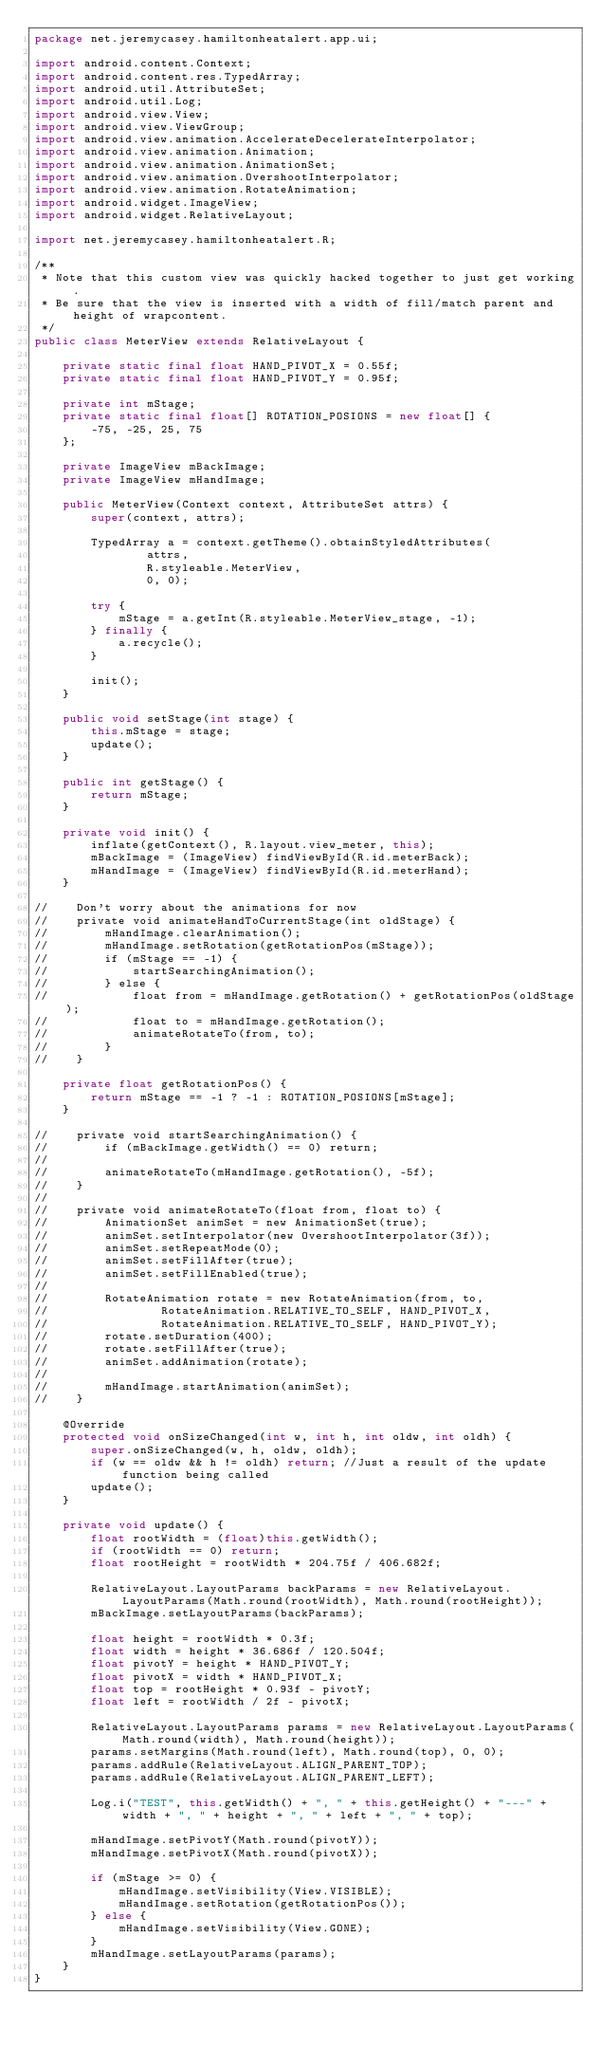<code> <loc_0><loc_0><loc_500><loc_500><_Java_>package net.jeremycasey.hamiltonheatalert.app.ui;

import android.content.Context;
import android.content.res.TypedArray;
import android.util.AttributeSet;
import android.util.Log;
import android.view.View;
import android.view.ViewGroup;
import android.view.animation.AccelerateDecelerateInterpolator;
import android.view.animation.Animation;
import android.view.animation.AnimationSet;
import android.view.animation.OvershootInterpolator;
import android.view.animation.RotateAnimation;
import android.widget.ImageView;
import android.widget.RelativeLayout;

import net.jeremycasey.hamiltonheatalert.R;

/**
 * Note that this custom view was quickly hacked together to just get working.
 * Be sure that the view is inserted with a width of fill/match parent and height of wrapcontent.
 */
public class MeterView extends RelativeLayout {

    private static final float HAND_PIVOT_X = 0.55f;
    private static final float HAND_PIVOT_Y = 0.95f;

    private int mStage;
    private static final float[] ROTATION_POSIONS = new float[] {
        -75, -25, 25, 75
    };

    private ImageView mBackImage;
    private ImageView mHandImage;

    public MeterView(Context context, AttributeSet attrs) {
        super(context, attrs);

        TypedArray a = context.getTheme().obtainStyledAttributes(
                attrs,
                R.styleable.MeterView,
                0, 0);

        try {
            mStage = a.getInt(R.styleable.MeterView_stage, -1);
        } finally {
            a.recycle();
        }

        init();
    }

    public void setStage(int stage) {
        this.mStage = stage;
        update();
    }

    public int getStage() {
        return mStage;
    }

    private void init() {
        inflate(getContext(), R.layout.view_meter, this);
        mBackImage = (ImageView) findViewById(R.id.meterBack);
        mHandImage = (ImageView) findViewById(R.id.meterHand);
    }

//    Don't worry about the animations for now
//    private void animateHandToCurrentStage(int oldStage) {
//        mHandImage.clearAnimation();
//        mHandImage.setRotation(getRotationPos(mStage));
//        if (mStage == -1) {
//            startSearchingAnimation();
//        } else {
//            float from = mHandImage.getRotation() + getRotationPos(oldStage);
//            float to = mHandImage.getRotation();
//            animateRotateTo(from, to);
//        }
//    }

    private float getRotationPos() {
        return mStage == -1 ? -1 : ROTATION_POSIONS[mStage];
    }

//    private void startSearchingAnimation() {
//        if (mBackImage.getWidth() == 0) return;
//
//        animateRotateTo(mHandImage.getRotation(), -5f);
//    }
//
//    private void animateRotateTo(float from, float to) {
//        AnimationSet animSet = new AnimationSet(true);
//        animSet.setInterpolator(new OvershootInterpolator(3f));
//        animSet.setRepeatMode(0);
//        animSet.setFillAfter(true);
//        animSet.setFillEnabled(true);
//
//        RotateAnimation rotate = new RotateAnimation(from, to,
//                RotateAnimation.RELATIVE_TO_SELF, HAND_PIVOT_X,
//                RotateAnimation.RELATIVE_TO_SELF, HAND_PIVOT_Y);
//        rotate.setDuration(400);
//        rotate.setFillAfter(true);
//        animSet.addAnimation(rotate);
//
//        mHandImage.startAnimation(animSet);
//    }

    @Override
    protected void onSizeChanged(int w, int h, int oldw, int oldh) {
        super.onSizeChanged(w, h, oldw, oldh);
        if (w == oldw && h != oldh) return; //Just a result of the update function being called
        update();
    }

    private void update() {
        float rootWidth = (float)this.getWidth();
        if (rootWidth == 0) return;
        float rootHeight = rootWidth * 204.75f / 406.682f;

        RelativeLayout.LayoutParams backParams = new RelativeLayout.LayoutParams(Math.round(rootWidth), Math.round(rootHeight));
        mBackImage.setLayoutParams(backParams);

        float height = rootWidth * 0.3f;
        float width = height * 36.686f / 120.504f;
        float pivotY = height * HAND_PIVOT_Y;
        float pivotX = width * HAND_PIVOT_X;
        float top = rootHeight * 0.93f - pivotY;
        float left = rootWidth / 2f - pivotX;

        RelativeLayout.LayoutParams params = new RelativeLayout.LayoutParams(Math.round(width), Math.round(height));
        params.setMargins(Math.round(left), Math.round(top), 0, 0);
        params.addRule(RelativeLayout.ALIGN_PARENT_TOP);
        params.addRule(RelativeLayout.ALIGN_PARENT_LEFT);

        Log.i("TEST", this.getWidth() + ", " + this.getHeight() + "---" + width + ", " + height + ", " + left + ", " + top);

        mHandImage.setPivotY(Math.round(pivotY));
        mHandImage.setPivotX(Math.round(pivotX));

        if (mStage >= 0) {
            mHandImage.setVisibility(View.VISIBLE);
            mHandImage.setRotation(getRotationPos());
        } else {
            mHandImage.setVisibility(View.GONE);
        }
        mHandImage.setLayoutParams(params);
    }
}
</code> 